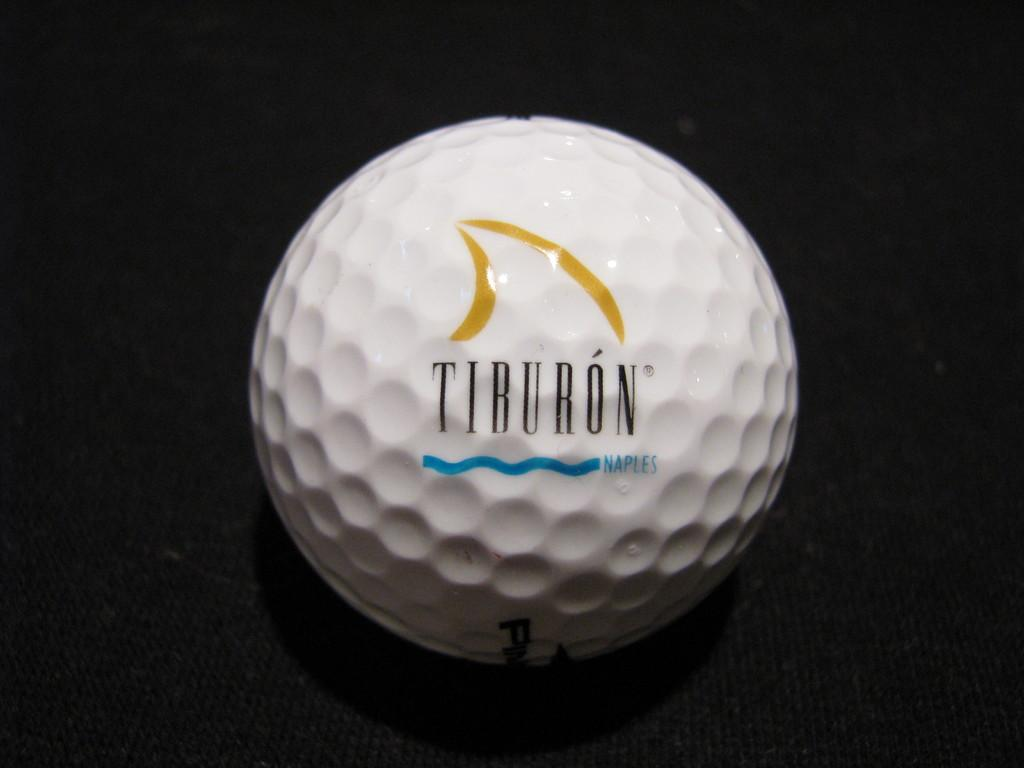<image>
Provide a brief description of the given image. Tuburon golf ball that is from naples with the water logo on the ball. 